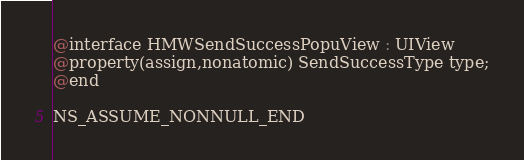Convert code to text. <code><loc_0><loc_0><loc_500><loc_500><_C_>
@interface HMWSendSuccessPopuView : UIView
@property(assign,nonatomic) SendSuccessType type;
@end

NS_ASSUME_NONNULL_END
</code> 